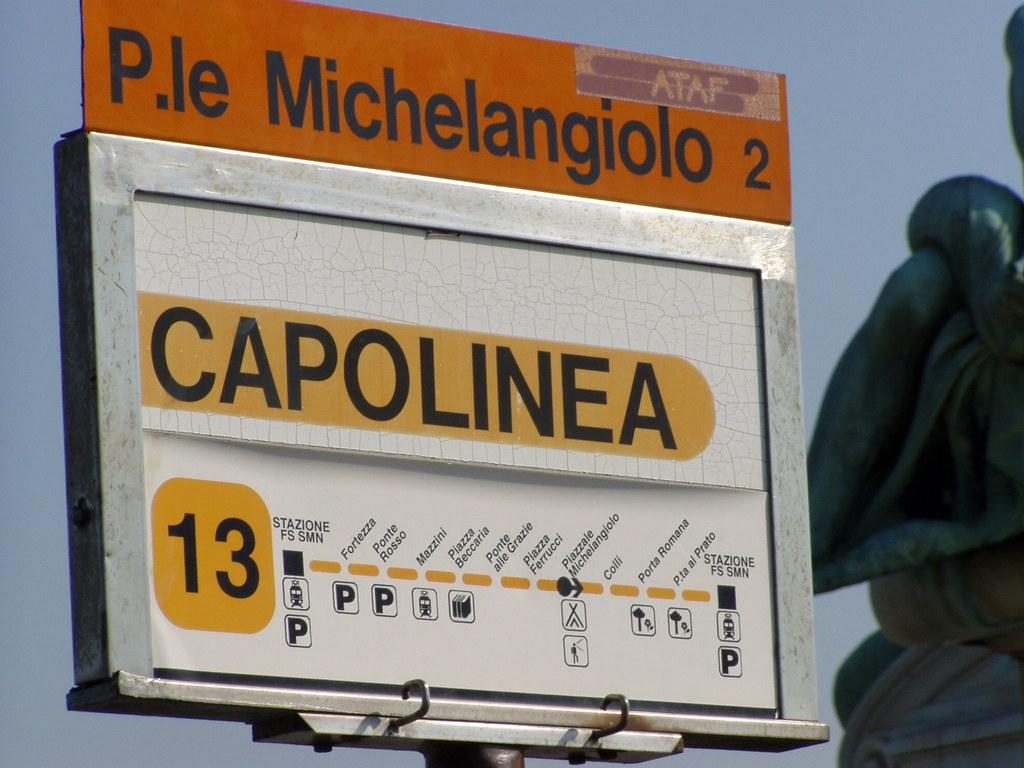<image>
Create a compact narrative representing the image presented. a billboard that says 'michelangiolo 2' on it 